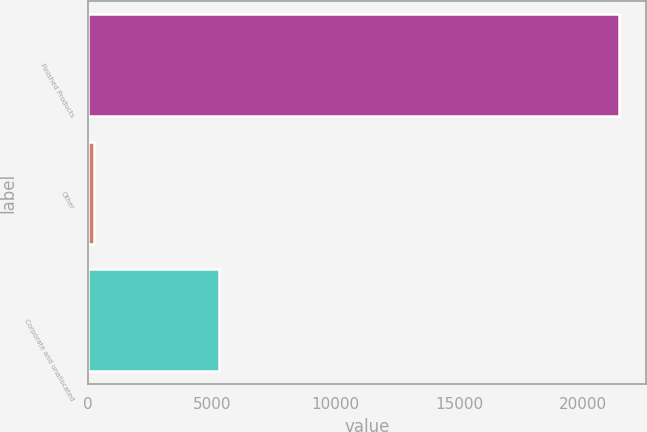<chart> <loc_0><loc_0><loc_500><loc_500><bar_chart><fcel>Finished Products<fcel>Other<fcel>Corporate and unallocated<nl><fcel>21464<fcel>231<fcel>5297<nl></chart> 